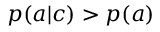<formula> <loc_0><loc_0><loc_500><loc_500>p ( a | c ) > p ( a )</formula> 